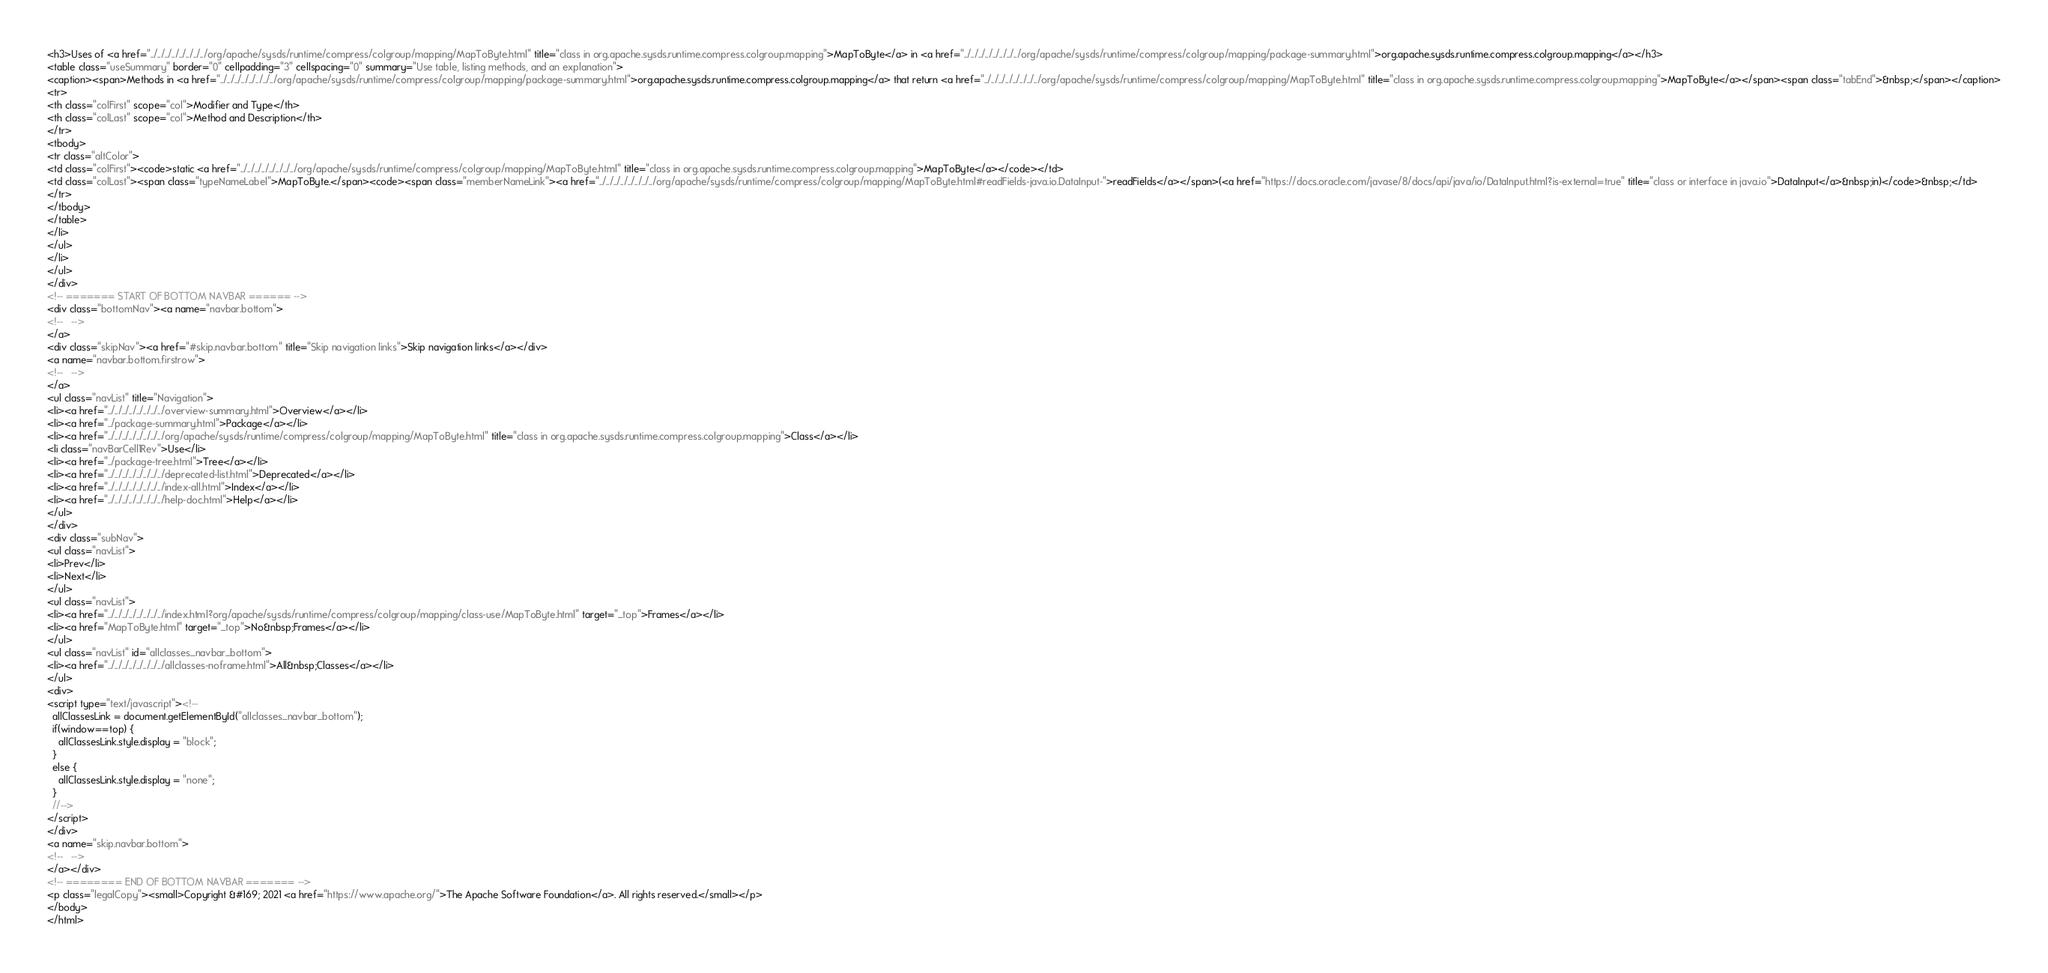<code> <loc_0><loc_0><loc_500><loc_500><_HTML_><h3>Uses of <a href="../../../../../../../../org/apache/sysds/runtime/compress/colgroup/mapping/MapToByte.html" title="class in org.apache.sysds.runtime.compress.colgroup.mapping">MapToByte</a> in <a href="../../../../../../../../org/apache/sysds/runtime/compress/colgroup/mapping/package-summary.html">org.apache.sysds.runtime.compress.colgroup.mapping</a></h3>
<table class="useSummary" border="0" cellpadding="3" cellspacing="0" summary="Use table, listing methods, and an explanation">
<caption><span>Methods in <a href="../../../../../../../../org/apache/sysds/runtime/compress/colgroup/mapping/package-summary.html">org.apache.sysds.runtime.compress.colgroup.mapping</a> that return <a href="../../../../../../../../org/apache/sysds/runtime/compress/colgroup/mapping/MapToByte.html" title="class in org.apache.sysds.runtime.compress.colgroup.mapping">MapToByte</a></span><span class="tabEnd">&nbsp;</span></caption>
<tr>
<th class="colFirst" scope="col">Modifier and Type</th>
<th class="colLast" scope="col">Method and Description</th>
</tr>
<tbody>
<tr class="altColor">
<td class="colFirst"><code>static <a href="../../../../../../../../org/apache/sysds/runtime/compress/colgroup/mapping/MapToByte.html" title="class in org.apache.sysds.runtime.compress.colgroup.mapping">MapToByte</a></code></td>
<td class="colLast"><span class="typeNameLabel">MapToByte.</span><code><span class="memberNameLink"><a href="../../../../../../../../org/apache/sysds/runtime/compress/colgroup/mapping/MapToByte.html#readFields-java.io.DataInput-">readFields</a></span>(<a href="https://docs.oracle.com/javase/8/docs/api/java/io/DataInput.html?is-external=true" title="class or interface in java.io">DataInput</a>&nbsp;in)</code>&nbsp;</td>
</tr>
</tbody>
</table>
</li>
</ul>
</li>
</ul>
</div>
<!-- ======= START OF BOTTOM NAVBAR ====== -->
<div class="bottomNav"><a name="navbar.bottom">
<!--   -->
</a>
<div class="skipNav"><a href="#skip.navbar.bottom" title="Skip navigation links">Skip navigation links</a></div>
<a name="navbar.bottom.firstrow">
<!--   -->
</a>
<ul class="navList" title="Navigation">
<li><a href="../../../../../../../../overview-summary.html">Overview</a></li>
<li><a href="../package-summary.html">Package</a></li>
<li><a href="../../../../../../../../org/apache/sysds/runtime/compress/colgroup/mapping/MapToByte.html" title="class in org.apache.sysds.runtime.compress.colgroup.mapping">Class</a></li>
<li class="navBarCell1Rev">Use</li>
<li><a href="../package-tree.html">Tree</a></li>
<li><a href="../../../../../../../../deprecated-list.html">Deprecated</a></li>
<li><a href="../../../../../../../../index-all.html">Index</a></li>
<li><a href="../../../../../../../../help-doc.html">Help</a></li>
</ul>
</div>
<div class="subNav">
<ul class="navList">
<li>Prev</li>
<li>Next</li>
</ul>
<ul class="navList">
<li><a href="../../../../../../../../index.html?org/apache/sysds/runtime/compress/colgroup/mapping/class-use/MapToByte.html" target="_top">Frames</a></li>
<li><a href="MapToByte.html" target="_top">No&nbsp;Frames</a></li>
</ul>
<ul class="navList" id="allclasses_navbar_bottom">
<li><a href="../../../../../../../../allclasses-noframe.html">All&nbsp;Classes</a></li>
</ul>
<div>
<script type="text/javascript"><!--
  allClassesLink = document.getElementById("allclasses_navbar_bottom");
  if(window==top) {
    allClassesLink.style.display = "block";
  }
  else {
    allClassesLink.style.display = "none";
  }
  //-->
</script>
</div>
<a name="skip.navbar.bottom">
<!--   -->
</a></div>
<!-- ======== END OF BOTTOM NAVBAR ======= -->
<p class="legalCopy"><small>Copyright &#169; 2021 <a href="https://www.apache.org/">The Apache Software Foundation</a>. All rights reserved.</small></p>
</body>
</html>
</code> 